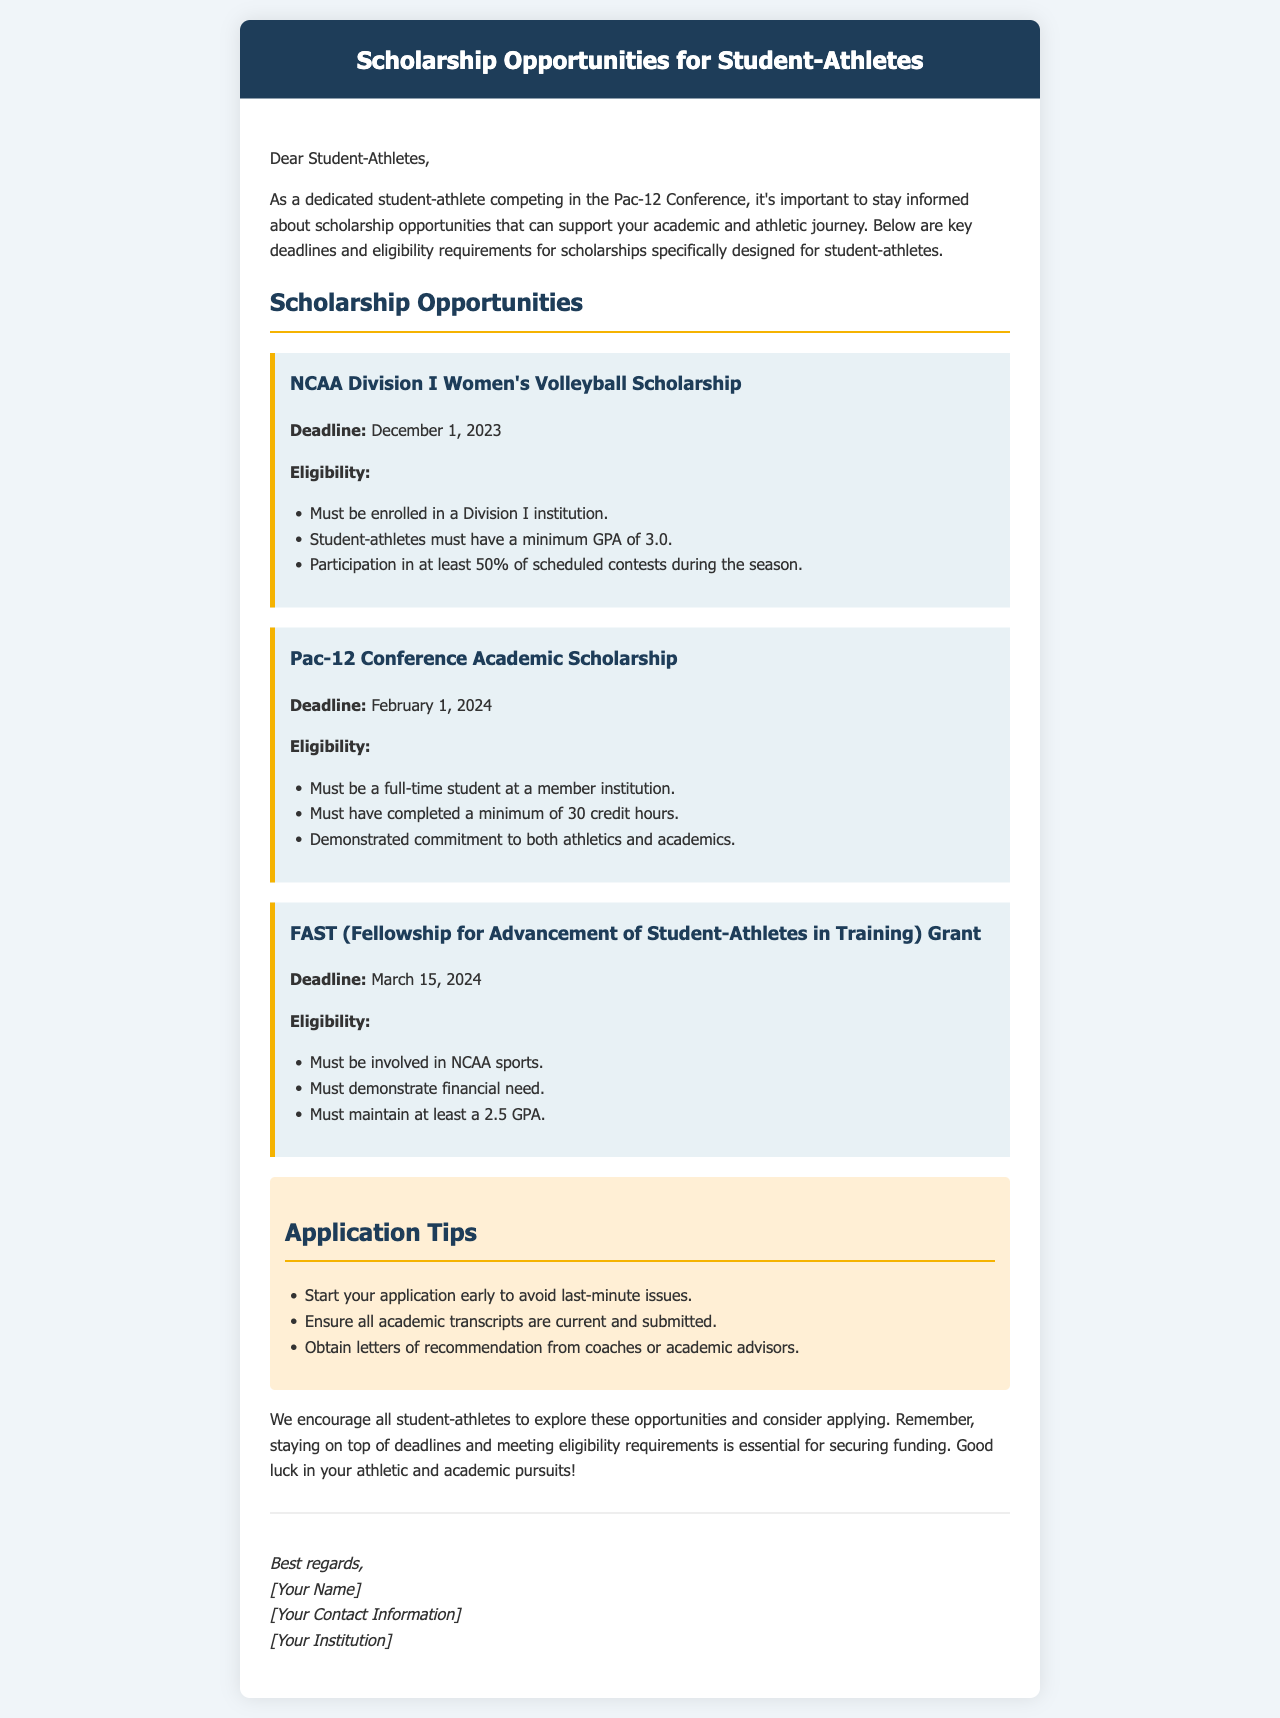What is the deadline for the NCAA Division I Women's Volleyball Scholarship? The deadline is clearly specified in the document as December 1, 2023.
Answer: December 1, 2023 What is the minimum GPA requirement for the FAST Grant? The document states that applicants must maintain at least a 2.5 GPA.
Answer: 2.5 GPA What is the total number of scholarships mentioned in the document? There are three scholarships outlined in the email.
Answer: Three What is a key eligibility requirement for the Pac-12 Conference Academic Scholarship? One key eligibility requirement is that the student must have completed a minimum of 30 credit hours.
Answer: Minimum of 30 credit hours What is one application tip provided in the email? One tip suggests starting the application early to avoid last-minute issues.
Answer: Start early How does a student-athlete demonstrate financial need for the FAST Grant? The document specifies that the applicant must demonstrate financial need.
Answer: Demonstrate financial need What is the maximum credit hours completed for the Pac-12 Conference Academic Scholarship eligibility? The requirement is that a student must have completed a minimum, not a maximum, of 30 credit hours. This is the only specified credit hour requirement mentioned.
Answer: Minimum of 30 credit hours What is the email's main purpose? The email aims to inform student-athletes about scholarship opportunities and their requirements.
Answer: Inform about scholarships 